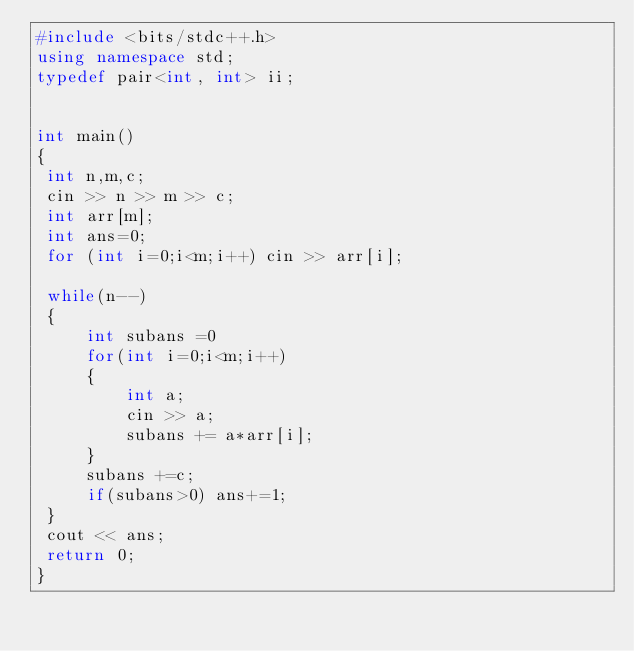<code> <loc_0><loc_0><loc_500><loc_500><_C++_>#include <bits/stdc++.h>
using namespace std;
typedef pair<int, int> ii;


int main()
{
 int n,m,c;
 cin >> n >> m >> c;
 int arr[m];
 int ans=0;
 for (int i=0;i<m;i++) cin >> arr[i];
 
 while(n--)
 {
     int subans =0
     for(int i=0;i<m;i++)
     {
         int a;
         cin >> a;
         subans += a*arr[i];
     }
     subans +=c;
     if(subans>0) ans+=1;
 }
 cout << ans;
 return 0;
}</code> 